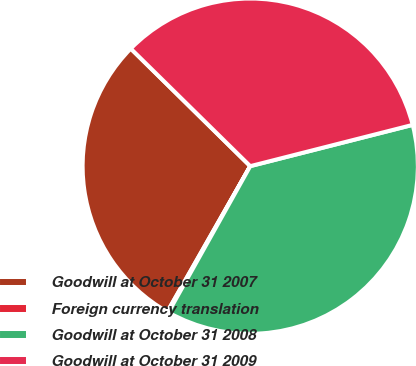<chart> <loc_0><loc_0><loc_500><loc_500><pie_chart><fcel>Goodwill at October 31 2007<fcel>Foreign currency translation<fcel>Goodwill at October 31 2008<fcel>Goodwill at October 31 2009<nl><fcel>29.13%<fcel>0.12%<fcel>37.08%<fcel>33.67%<nl></chart> 